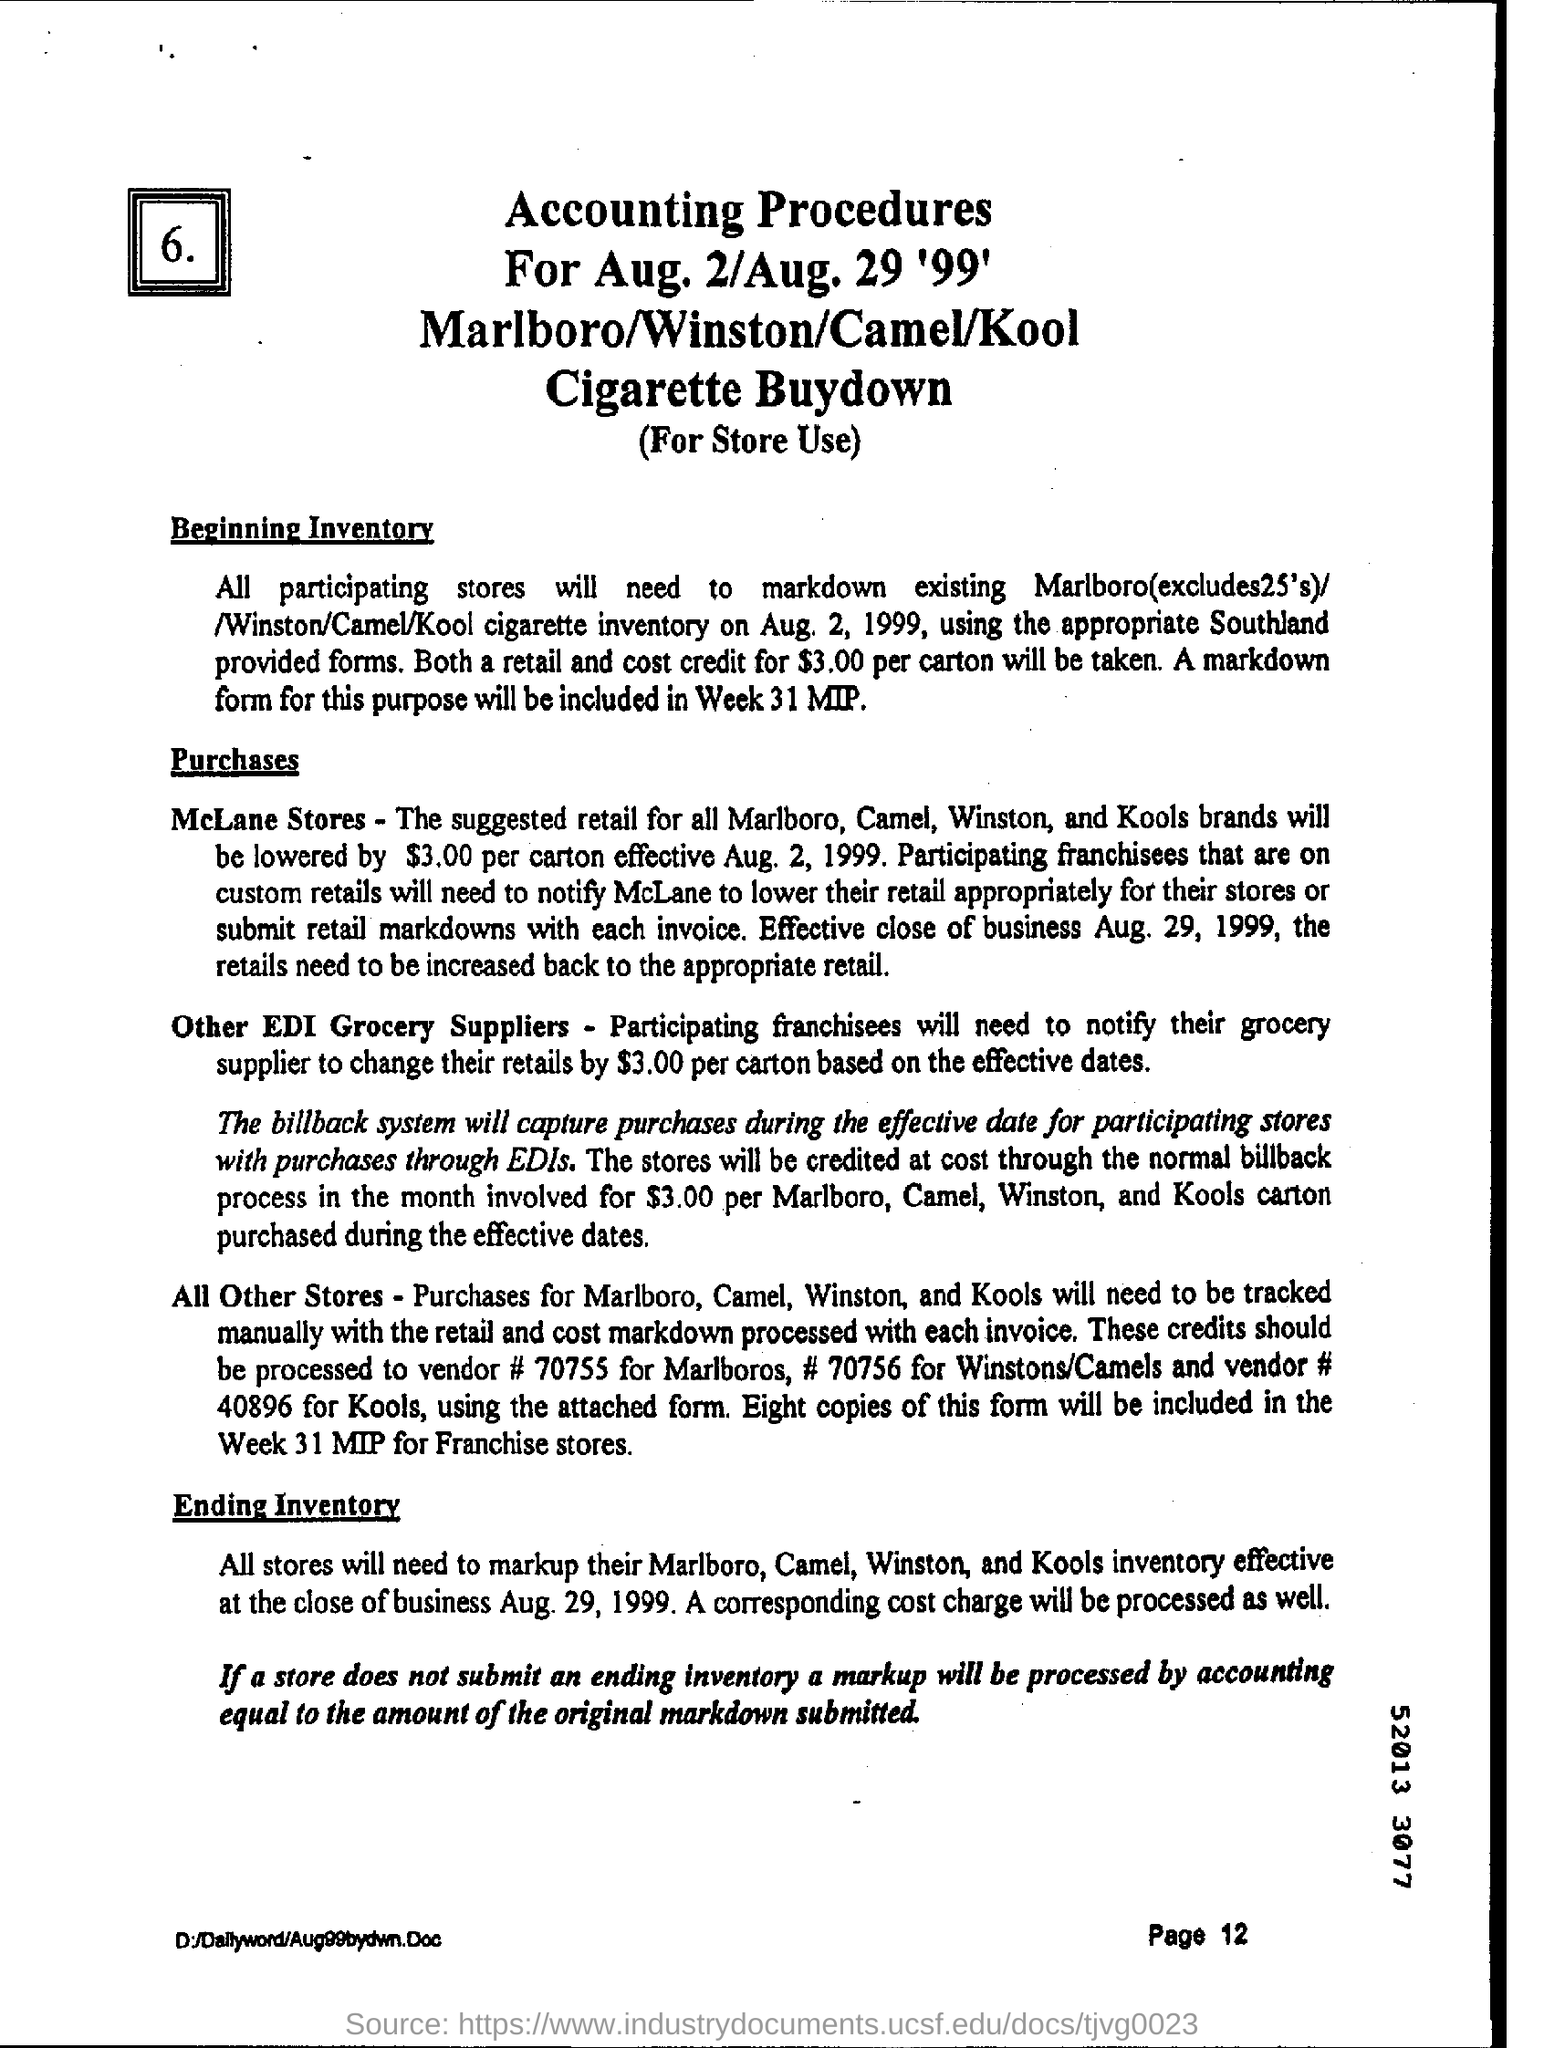What is the page number written on the bottom?
 Page 12 